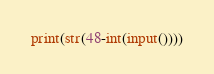<code> <loc_0><loc_0><loc_500><loc_500><_Python_>print(str(48-int(input())))</code> 